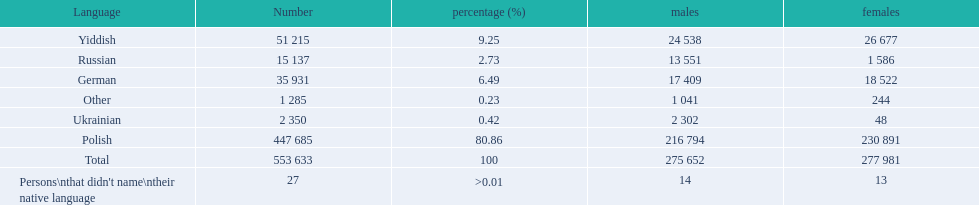What languages are there? Polish, Yiddish, German, Russian, Ukrainian. What numbers speak these languages? 447 685, 51 215, 35 931, 15 137, 2 350. What numbers are not listed as speaking these languages? 1 285, 27. What are the totals of these speakers? 553 633. 